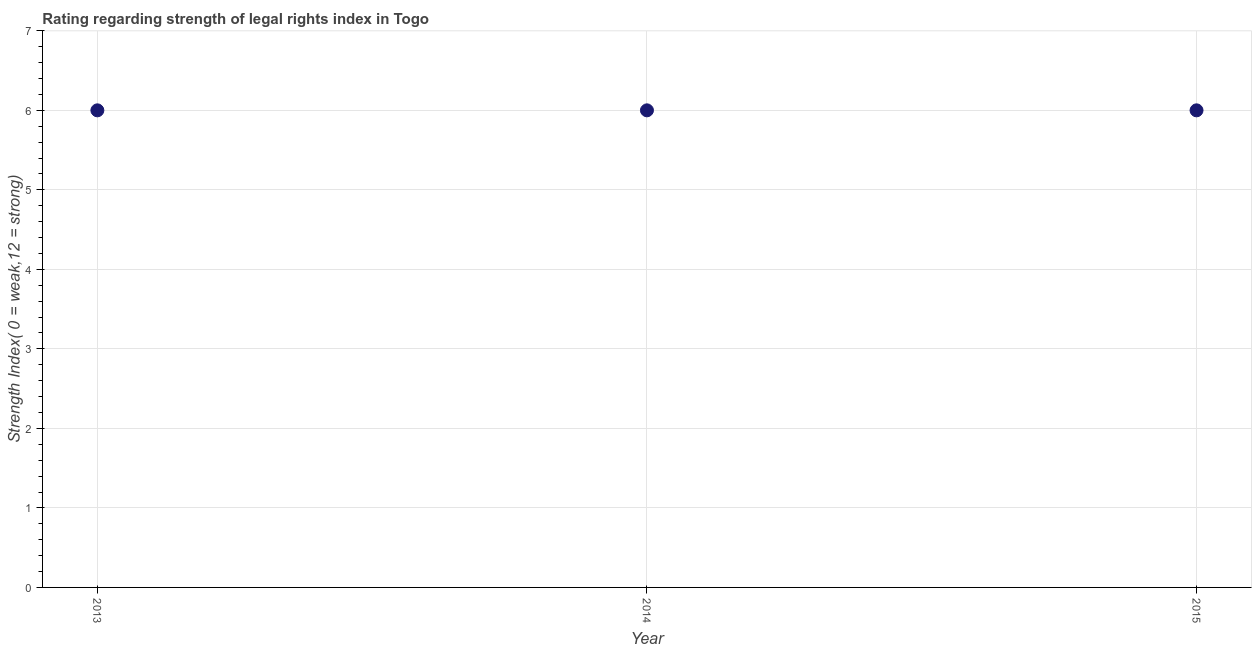Across all years, what is the maximum strength of legal rights index?
Keep it short and to the point. 6. Across all years, what is the minimum strength of legal rights index?
Offer a terse response. 6. In which year was the strength of legal rights index maximum?
Offer a terse response. 2013. In which year was the strength of legal rights index minimum?
Offer a terse response. 2013. What is the sum of the strength of legal rights index?
Keep it short and to the point. 18. What is the median strength of legal rights index?
Make the answer very short. 6. Is the difference between the strength of legal rights index in 2014 and 2015 greater than the difference between any two years?
Provide a succinct answer. Yes. What is the difference between the highest and the second highest strength of legal rights index?
Ensure brevity in your answer.  0. Is the sum of the strength of legal rights index in 2014 and 2015 greater than the maximum strength of legal rights index across all years?
Your response must be concise. Yes. In how many years, is the strength of legal rights index greater than the average strength of legal rights index taken over all years?
Ensure brevity in your answer.  0. How many years are there in the graph?
Ensure brevity in your answer.  3. What is the title of the graph?
Offer a very short reply. Rating regarding strength of legal rights index in Togo. What is the label or title of the Y-axis?
Offer a terse response. Strength Index( 0 = weak,12 = strong). What is the Strength Index( 0 = weak,12 = strong) in 2014?
Offer a very short reply. 6. What is the difference between the Strength Index( 0 = weak,12 = strong) in 2013 and 2014?
Ensure brevity in your answer.  0. What is the difference between the Strength Index( 0 = weak,12 = strong) in 2014 and 2015?
Make the answer very short. 0. What is the ratio of the Strength Index( 0 = weak,12 = strong) in 2014 to that in 2015?
Offer a very short reply. 1. 